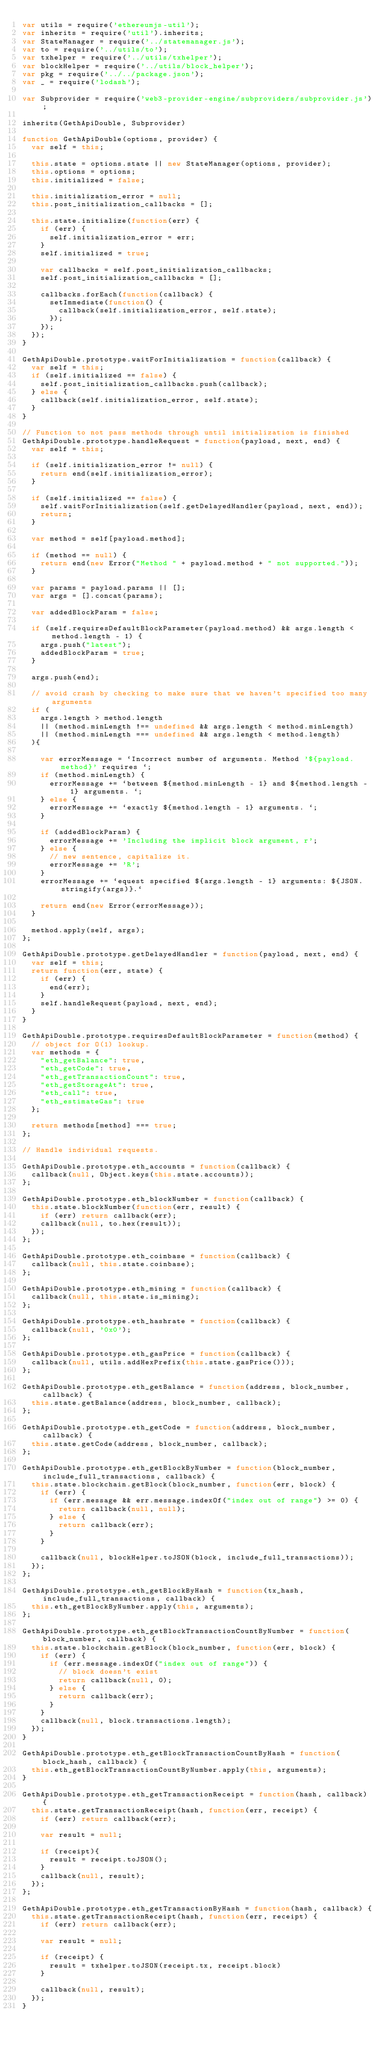<code> <loc_0><loc_0><loc_500><loc_500><_JavaScript_>var utils = require('ethereumjs-util');
var inherits = require('util').inherits;
var StateManager = require('../statemanager.js');
var to = require('../utils/to');
var txhelper = require('../utils/txhelper');
var blockHelper = require('../utils/block_helper');
var pkg = require('../../package.json');
var _ = require('lodash');

var Subprovider = require('web3-provider-engine/subproviders/subprovider.js');

inherits(GethApiDouble, Subprovider)

function GethApiDouble(options, provider) {
  var self = this;

  this.state = options.state || new StateManager(options, provider);
  this.options = options;
  this.initialized = false;

  this.initialization_error = null;
  this.post_initialization_callbacks = [];

  this.state.initialize(function(err) {
    if (err) {
      self.initialization_error = err;
    }
    self.initialized = true;

    var callbacks = self.post_initialization_callbacks;
    self.post_initialization_callbacks = [];

    callbacks.forEach(function(callback) {
      setImmediate(function() {
        callback(self.initialization_error, self.state);
      });
    });
  });
}

GethApiDouble.prototype.waitForInitialization = function(callback) {
  var self = this;
  if (self.initialized == false) {
    self.post_initialization_callbacks.push(callback);
  } else {
    callback(self.initialization_error, self.state);
  }
}

// Function to not pass methods through until initialization is finished
GethApiDouble.prototype.handleRequest = function(payload, next, end) {
  var self = this;

  if (self.initialization_error != null) {
    return end(self.initialization_error);
  }

  if (self.initialized == false) {
    self.waitForInitialization(self.getDelayedHandler(payload, next, end));
    return;
  }

  var method = self[payload.method];

  if (method == null) {
    return end(new Error("Method " + payload.method + " not supported."));
  }

  var params = payload.params || [];
  var args = [].concat(params);

  var addedBlockParam = false;

  if (self.requiresDefaultBlockParameter(payload.method) && args.length < method.length - 1) {
    args.push("latest");
    addedBlockParam = true;
  }

  args.push(end);

  // avoid crash by checking to make sure that we haven't specified too many arguments
  if (
    args.length > method.length
    || (method.minLength !== undefined && args.length < method.minLength)
    || (method.minLength === undefined && args.length < method.length)
  ){

    var errorMessage = `Incorrect number of arguments. Method '${payload.method}' requires `;
    if (method.minLength) {
      errorMessage += `between ${method.minLength - 1} and ${method.length - 1} arguments. `;
    } else {
      errorMessage += `exactly ${method.length - 1} arguments. `;
    }

    if (addedBlockParam) {
      errorMessage += 'Including the implicit block argument, r';
    } else {
      // new sentence, capitalize it.
      errorMessage += 'R';
    }
    errorMessage += `equest specified ${args.length - 1} arguments: ${JSON.stringify(args)}.`

    return end(new Error(errorMessage));
  }

  method.apply(self, args);
};

GethApiDouble.prototype.getDelayedHandler = function(payload, next, end) {
  var self = this;
  return function(err, state) {
    if (err) {
      end(err);
    }
    self.handleRequest(payload, next, end);
  }
}

GethApiDouble.prototype.requiresDefaultBlockParameter = function(method) {
  // object for O(1) lookup.
  var methods = {
    "eth_getBalance": true,
    "eth_getCode": true,
    "eth_getTransactionCount": true,
    "eth_getStorageAt": true,
    "eth_call": true,
    "eth_estimateGas": true
  };

  return methods[method] === true;
};

// Handle individual requests.

GethApiDouble.prototype.eth_accounts = function(callback) {
  callback(null, Object.keys(this.state.accounts));
};

GethApiDouble.prototype.eth_blockNumber = function(callback) {
  this.state.blockNumber(function(err, result) {
    if (err) return callback(err);
    callback(null, to.hex(result));
  });
};

GethApiDouble.prototype.eth_coinbase = function(callback) {
  callback(null, this.state.coinbase);
};

GethApiDouble.prototype.eth_mining = function(callback) {
  callback(null, this.state.is_mining);
};

GethApiDouble.prototype.eth_hashrate = function(callback) {
  callback(null, '0x0');
};

GethApiDouble.prototype.eth_gasPrice = function(callback) {
  callback(null, utils.addHexPrefix(this.state.gasPrice()));
};

GethApiDouble.prototype.eth_getBalance = function(address, block_number, callback) {
  this.state.getBalance(address, block_number, callback);
};

GethApiDouble.prototype.eth_getCode = function(address, block_number, callback) {
  this.state.getCode(address, block_number, callback);
};

GethApiDouble.prototype.eth_getBlockByNumber = function(block_number, include_full_transactions, callback) {
  this.state.blockchain.getBlock(block_number, function(err, block) {
    if (err) {
      if (err.message && err.message.indexOf("index out of range") >= 0) {
        return callback(null, null);
      } else {
        return callback(err);
      }
    }

    callback(null, blockHelper.toJSON(block, include_full_transactions));
  });
};

GethApiDouble.prototype.eth_getBlockByHash = function(tx_hash, include_full_transactions, callback) {
  this.eth_getBlockByNumber.apply(this, arguments);
};

GethApiDouble.prototype.eth_getBlockTransactionCountByNumber = function(block_number, callback) {
  this.state.blockchain.getBlock(block_number, function(err, block) {
    if (err) {
      if (err.message.indexOf("index out of range")) {
        // block doesn't exist
        return callback(null, 0);
      } else {
        return callback(err);
      }
    }
    callback(null, block.transactions.length);
  });
}

GethApiDouble.prototype.eth_getBlockTransactionCountByHash = function(block_hash, callback) {
  this.eth_getBlockTransactionCountByNumber.apply(this, arguments);
}

GethApiDouble.prototype.eth_getTransactionReceipt = function(hash, callback) {
  this.state.getTransactionReceipt(hash, function(err, receipt) {
    if (err) return callback(err);

    var result = null;

    if (receipt){
      result = receipt.toJSON();
    }
    callback(null, result);
  });
};

GethApiDouble.prototype.eth_getTransactionByHash = function(hash, callback) {
  this.state.getTransactionReceipt(hash, function(err, receipt) {
    if (err) return callback(err);

    var result = null;

    if (receipt) {
      result = txhelper.toJSON(receipt.tx, receipt.block)
    }

    callback(null, result);
  });
}
</code> 